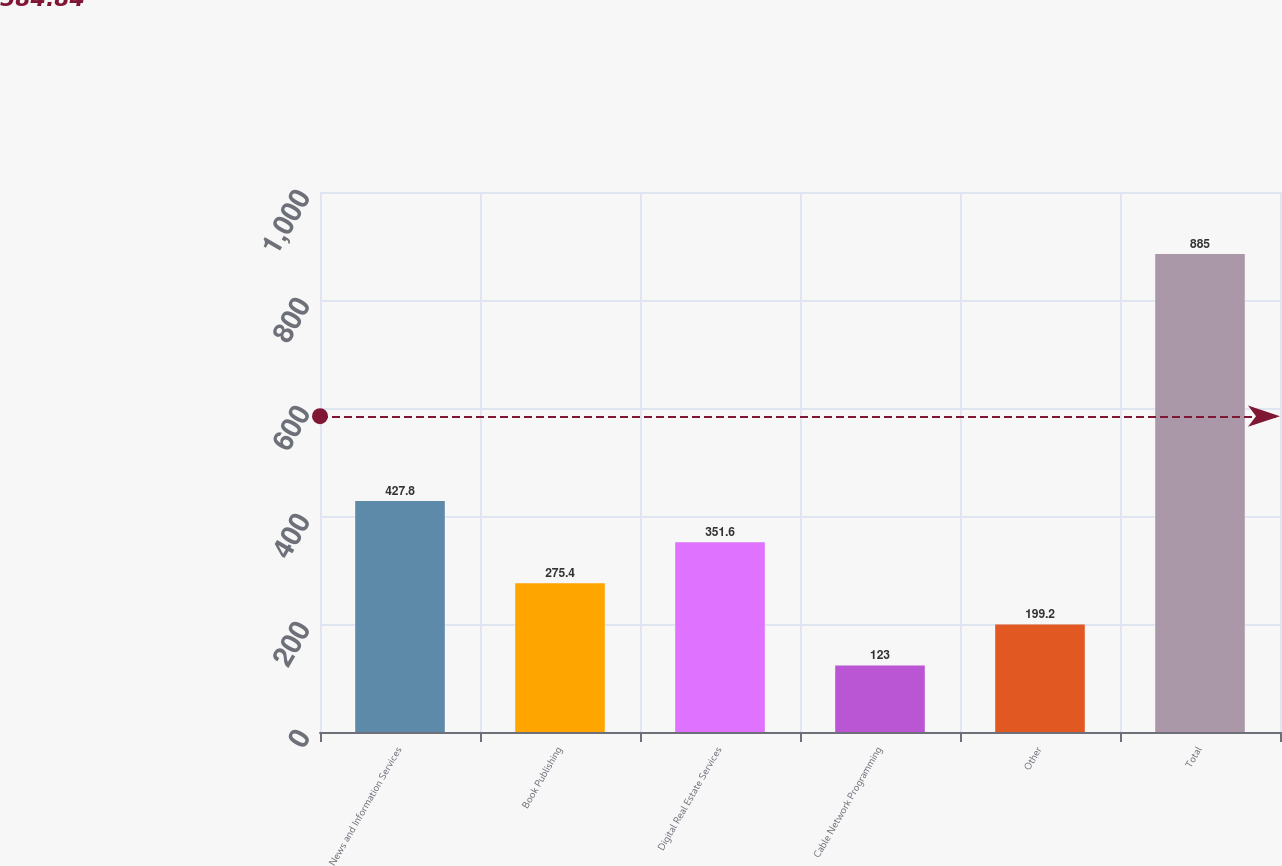<chart> <loc_0><loc_0><loc_500><loc_500><bar_chart><fcel>News and Information Services<fcel>Book Publishing<fcel>Digital Real Estate Services<fcel>Cable Network Programming<fcel>Other<fcel>Total<nl><fcel>427.8<fcel>275.4<fcel>351.6<fcel>123<fcel>199.2<fcel>885<nl></chart> 